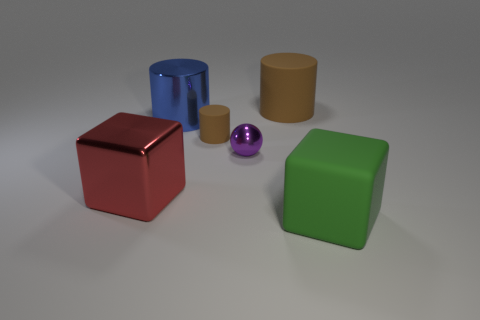How many big matte cylinders have the same color as the matte block?
Offer a very short reply. 0. Does the large red metallic thing have the same shape as the green matte object?
Your answer should be compact. Yes. What is the size of the blue object that is the same shape as the tiny brown thing?
Keep it short and to the point. Large. Is the number of things that are behind the purple shiny thing greater than the number of tiny brown objects on the right side of the big green matte cube?
Keep it short and to the point. Yes. Does the small ball have the same material as the large cube that is on the left side of the big blue cylinder?
Provide a short and direct response. Yes. Are there any other things that have the same shape as the green rubber object?
Your response must be concise. Yes. What color is the large object that is both behind the ball and on the left side of the tiny metallic thing?
Make the answer very short. Blue. What shape is the object on the left side of the blue metal object?
Provide a succinct answer. Cube. There is a cube that is on the right side of the brown rubber cylinder that is left of the ball that is in front of the large blue cylinder; what is its size?
Your answer should be compact. Large. There is a matte thing that is behind the metallic cylinder; how many large metal blocks are in front of it?
Offer a terse response. 1. 